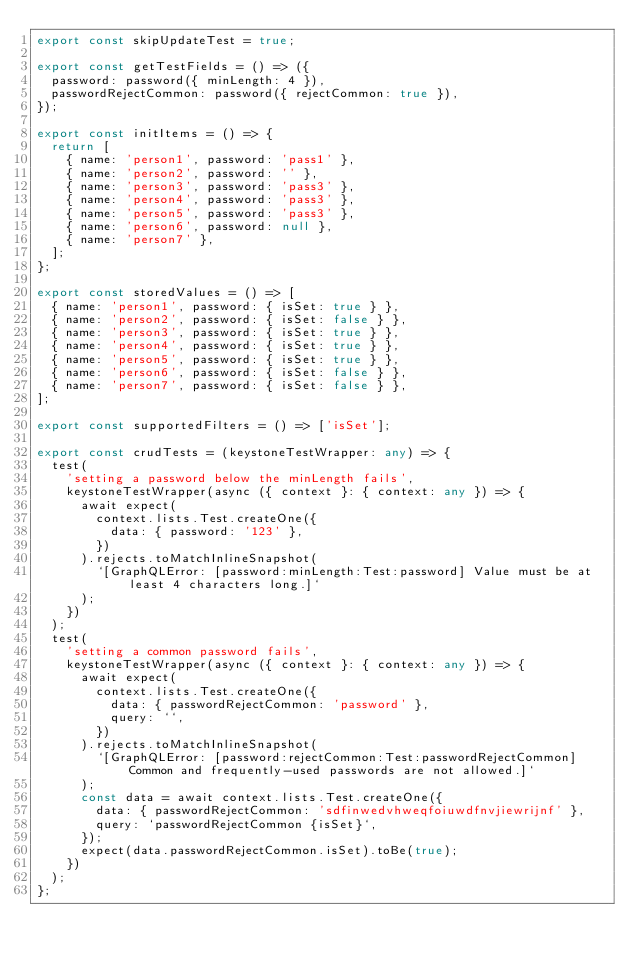<code> <loc_0><loc_0><loc_500><loc_500><_TypeScript_>export const skipUpdateTest = true;

export const getTestFields = () => ({
  password: password({ minLength: 4 }),
  passwordRejectCommon: password({ rejectCommon: true }),
});

export const initItems = () => {
  return [
    { name: 'person1', password: 'pass1' },
    { name: 'person2', password: '' },
    { name: 'person3', password: 'pass3' },
    { name: 'person4', password: 'pass3' },
    { name: 'person5', password: 'pass3' },
    { name: 'person6', password: null },
    { name: 'person7' },
  ];
};

export const storedValues = () => [
  { name: 'person1', password: { isSet: true } },
  { name: 'person2', password: { isSet: false } },
  { name: 'person3', password: { isSet: true } },
  { name: 'person4', password: { isSet: true } },
  { name: 'person5', password: { isSet: true } },
  { name: 'person6', password: { isSet: false } },
  { name: 'person7', password: { isSet: false } },
];

export const supportedFilters = () => ['isSet'];

export const crudTests = (keystoneTestWrapper: any) => {
  test(
    'setting a password below the minLength fails',
    keystoneTestWrapper(async ({ context }: { context: any }) => {
      await expect(
        context.lists.Test.createOne({
          data: { password: '123' },
        })
      ).rejects.toMatchInlineSnapshot(
        `[GraphQLError: [password:minLength:Test:password] Value must be at least 4 characters long.]`
      );
    })
  );
  test(
    'setting a common password fails',
    keystoneTestWrapper(async ({ context }: { context: any }) => {
      await expect(
        context.lists.Test.createOne({
          data: { passwordRejectCommon: 'password' },
          query: ``,
        })
      ).rejects.toMatchInlineSnapshot(
        `[GraphQLError: [password:rejectCommon:Test:passwordRejectCommon] Common and frequently-used passwords are not allowed.]`
      );
      const data = await context.lists.Test.createOne({
        data: { passwordRejectCommon: 'sdfinwedvhweqfoiuwdfnvjiewrijnf' },
        query: `passwordRejectCommon {isSet}`,
      });
      expect(data.passwordRejectCommon.isSet).toBe(true);
    })
  );
};
</code> 